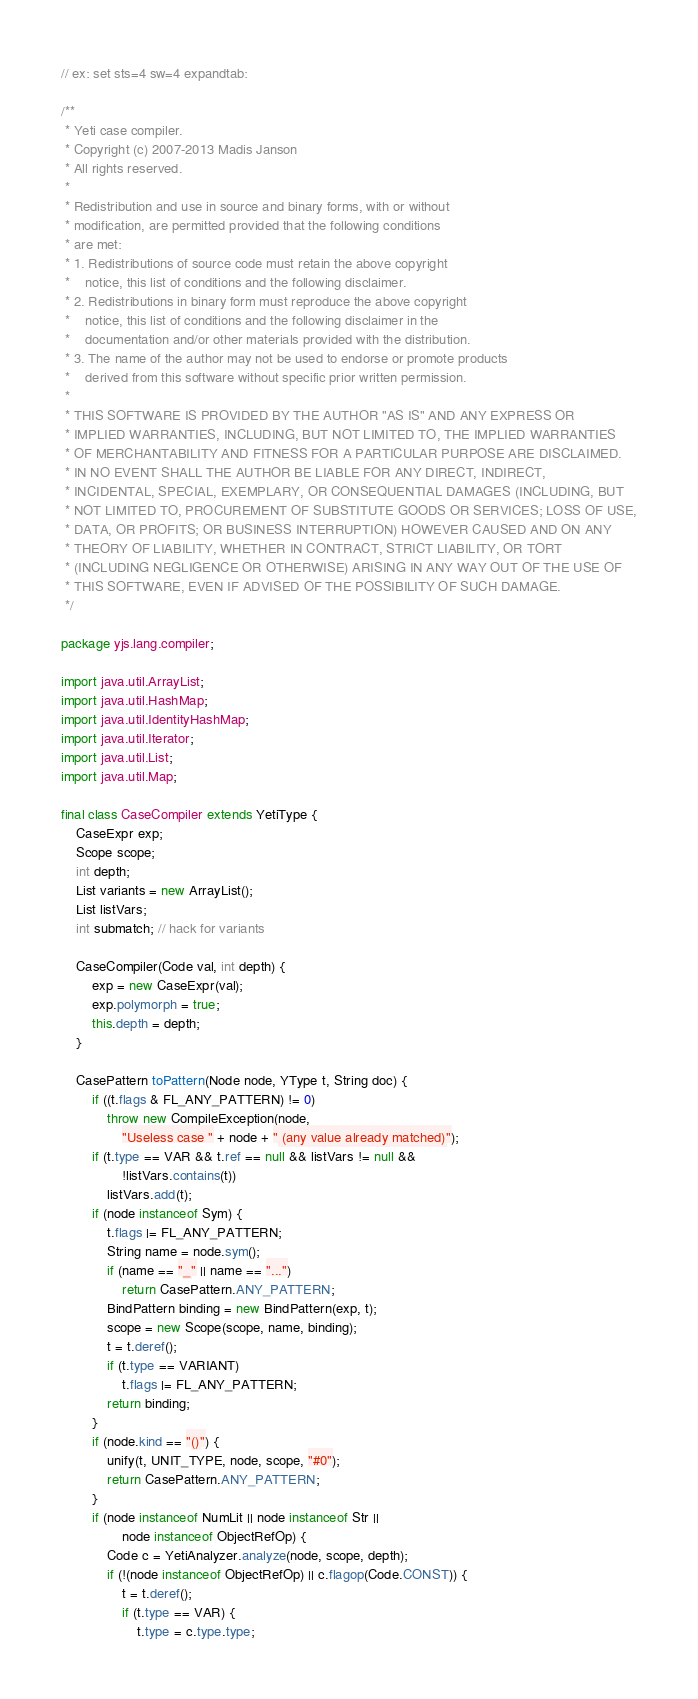<code> <loc_0><loc_0><loc_500><loc_500><_Java_>// ex: set sts=4 sw=4 expandtab:

/**
 * Yeti case compiler.
 * Copyright (c) 2007-2013 Madis Janson
 * All rights reserved.
 *
 * Redistribution and use in source and binary forms, with or without
 * modification, are permitted provided that the following conditions
 * are met:
 * 1. Redistributions of source code must retain the above copyright
 *    notice, this list of conditions and the following disclaimer.
 * 2. Redistributions in binary form must reproduce the above copyright
 *    notice, this list of conditions and the following disclaimer in the
 *    documentation and/or other materials provided with the distribution.
 * 3. The name of the author may not be used to endorse or promote products
 *    derived from this software without specific prior written permission.
 *
 * THIS SOFTWARE IS PROVIDED BY THE AUTHOR "AS IS" AND ANY EXPRESS OR
 * IMPLIED WARRANTIES, INCLUDING, BUT NOT LIMITED TO, THE IMPLIED WARRANTIES
 * OF MERCHANTABILITY AND FITNESS FOR A PARTICULAR PURPOSE ARE DISCLAIMED.
 * IN NO EVENT SHALL THE AUTHOR BE LIABLE FOR ANY DIRECT, INDIRECT,
 * INCIDENTAL, SPECIAL, EXEMPLARY, OR CONSEQUENTIAL DAMAGES (INCLUDING, BUT
 * NOT LIMITED TO, PROCUREMENT OF SUBSTITUTE GOODS OR SERVICES; LOSS OF USE,
 * DATA, OR PROFITS; OR BUSINESS INTERRUPTION) HOWEVER CAUSED AND ON ANY
 * THEORY OF LIABILITY, WHETHER IN CONTRACT, STRICT LIABILITY, OR TORT
 * (INCLUDING NEGLIGENCE OR OTHERWISE) ARISING IN ANY WAY OUT OF THE USE OF
 * THIS SOFTWARE, EVEN IF ADVISED OF THE POSSIBILITY OF SUCH DAMAGE.
 */

package yjs.lang.compiler;

import java.util.ArrayList;
import java.util.HashMap;
import java.util.IdentityHashMap;
import java.util.Iterator;
import java.util.List;
import java.util.Map;

final class CaseCompiler extends YetiType {
    CaseExpr exp;
    Scope scope;
    int depth;
    List variants = new ArrayList();
    List listVars;
    int submatch; // hack for variants

    CaseCompiler(Code val, int depth) {
        exp = new CaseExpr(val);
        exp.polymorph = true;
        this.depth = depth;
    }

    CasePattern toPattern(Node node, YType t, String doc) {
        if ((t.flags & FL_ANY_PATTERN) != 0)
            throw new CompileException(node,
                "Useless case " + node + " (any value already matched)");
        if (t.type == VAR && t.ref == null && listVars != null &&
                !listVars.contains(t))
            listVars.add(t);
        if (node instanceof Sym) {
            t.flags |= FL_ANY_PATTERN;
            String name = node.sym();
            if (name == "_" || name == "...")
                return CasePattern.ANY_PATTERN;
            BindPattern binding = new BindPattern(exp, t);
            scope = new Scope(scope, name, binding);
            t = t.deref();
            if (t.type == VARIANT)
                t.flags |= FL_ANY_PATTERN;
            return binding;
        }
        if (node.kind == "()") {
            unify(t, UNIT_TYPE, node, scope, "#0");
            return CasePattern.ANY_PATTERN;
        }
        if (node instanceof NumLit || node instanceof Str ||
                node instanceof ObjectRefOp) {
            Code c = YetiAnalyzer.analyze(node, scope, depth);
            if (!(node instanceof ObjectRefOp) || c.flagop(Code.CONST)) {
                t = t.deref();
                if (t.type == VAR) {
                    t.type = c.type.type;</code> 